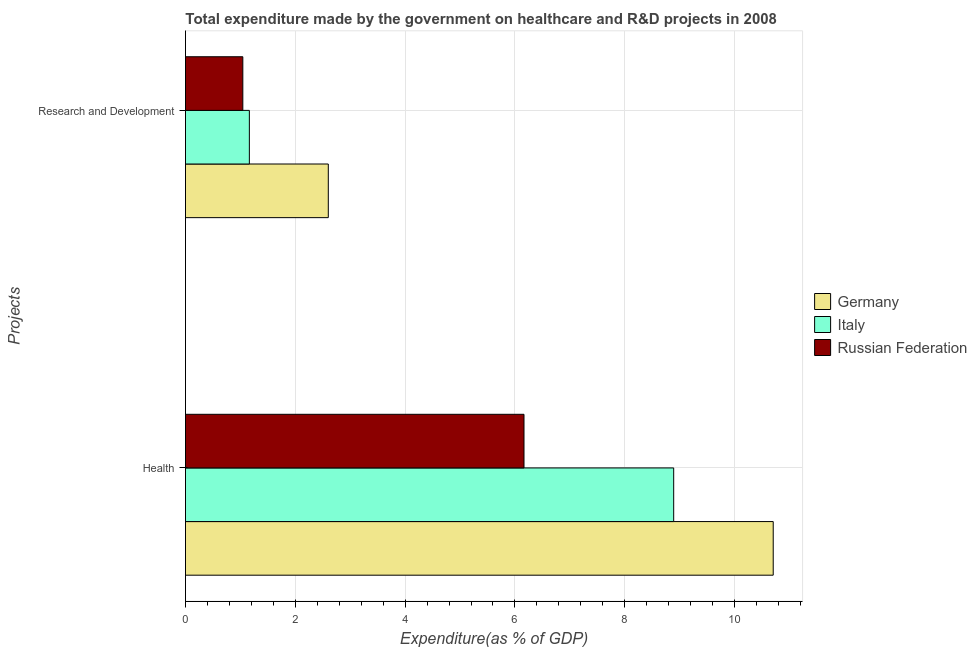How many different coloured bars are there?
Give a very brief answer. 3. How many groups of bars are there?
Provide a succinct answer. 2. Are the number of bars on each tick of the Y-axis equal?
Your response must be concise. Yes. How many bars are there on the 2nd tick from the bottom?
Provide a short and direct response. 3. What is the label of the 1st group of bars from the top?
Keep it short and to the point. Research and Development. What is the expenditure in healthcare in Russian Federation?
Provide a succinct answer. 6.17. Across all countries, what is the maximum expenditure in r&d?
Provide a short and direct response. 2.6. Across all countries, what is the minimum expenditure in healthcare?
Offer a terse response. 6.17. In which country was the expenditure in healthcare minimum?
Offer a terse response. Russian Federation. What is the total expenditure in r&d in the graph?
Provide a short and direct response. 4.81. What is the difference between the expenditure in healthcare in Italy and that in Germany?
Your response must be concise. -1.81. What is the difference between the expenditure in r&d in Russian Federation and the expenditure in healthcare in Italy?
Keep it short and to the point. -7.85. What is the average expenditure in r&d per country?
Keep it short and to the point. 1.6. What is the difference between the expenditure in r&d and expenditure in healthcare in Italy?
Your answer should be very brief. -7.73. What is the ratio of the expenditure in healthcare in Russian Federation to that in Germany?
Your answer should be compact. 0.58. Is the expenditure in healthcare in Italy less than that in Russian Federation?
Provide a succinct answer. No. What does the 2nd bar from the top in Research and Development represents?
Your answer should be compact. Italy. What does the 1st bar from the bottom in Research and Development represents?
Offer a very short reply. Germany. How many bars are there?
Give a very brief answer. 6. What is the difference between two consecutive major ticks on the X-axis?
Offer a terse response. 2. Are the values on the major ticks of X-axis written in scientific E-notation?
Offer a very short reply. No. Does the graph contain any zero values?
Give a very brief answer. No. How many legend labels are there?
Make the answer very short. 3. How are the legend labels stacked?
Offer a very short reply. Vertical. What is the title of the graph?
Your answer should be compact. Total expenditure made by the government on healthcare and R&D projects in 2008. Does "European Union" appear as one of the legend labels in the graph?
Provide a succinct answer. No. What is the label or title of the X-axis?
Provide a succinct answer. Expenditure(as % of GDP). What is the label or title of the Y-axis?
Ensure brevity in your answer.  Projects. What is the Expenditure(as % of GDP) of Germany in Health?
Offer a very short reply. 10.7. What is the Expenditure(as % of GDP) of Italy in Health?
Provide a succinct answer. 8.89. What is the Expenditure(as % of GDP) of Russian Federation in Health?
Provide a short and direct response. 6.17. What is the Expenditure(as % of GDP) of Germany in Research and Development?
Your answer should be compact. 2.6. What is the Expenditure(as % of GDP) of Italy in Research and Development?
Provide a short and direct response. 1.16. What is the Expenditure(as % of GDP) in Russian Federation in Research and Development?
Give a very brief answer. 1.04. Across all Projects, what is the maximum Expenditure(as % of GDP) of Germany?
Provide a short and direct response. 10.7. Across all Projects, what is the maximum Expenditure(as % of GDP) of Italy?
Make the answer very short. 8.89. Across all Projects, what is the maximum Expenditure(as % of GDP) in Russian Federation?
Offer a very short reply. 6.17. Across all Projects, what is the minimum Expenditure(as % of GDP) in Germany?
Make the answer very short. 2.6. Across all Projects, what is the minimum Expenditure(as % of GDP) in Italy?
Your answer should be compact. 1.16. Across all Projects, what is the minimum Expenditure(as % of GDP) of Russian Federation?
Make the answer very short. 1.04. What is the total Expenditure(as % of GDP) of Germany in the graph?
Ensure brevity in your answer.  13.3. What is the total Expenditure(as % of GDP) of Italy in the graph?
Provide a short and direct response. 10.05. What is the total Expenditure(as % of GDP) of Russian Federation in the graph?
Your response must be concise. 7.21. What is the difference between the Expenditure(as % of GDP) in Germany in Health and that in Research and Development?
Keep it short and to the point. 8.1. What is the difference between the Expenditure(as % of GDP) in Italy in Health and that in Research and Development?
Offer a very short reply. 7.73. What is the difference between the Expenditure(as % of GDP) in Russian Federation in Health and that in Research and Development?
Offer a terse response. 5.12. What is the difference between the Expenditure(as % of GDP) of Germany in Health and the Expenditure(as % of GDP) of Italy in Research and Development?
Your answer should be very brief. 9.54. What is the difference between the Expenditure(as % of GDP) in Germany in Health and the Expenditure(as % of GDP) in Russian Federation in Research and Development?
Keep it short and to the point. 9.66. What is the difference between the Expenditure(as % of GDP) in Italy in Health and the Expenditure(as % of GDP) in Russian Federation in Research and Development?
Give a very brief answer. 7.85. What is the average Expenditure(as % of GDP) in Germany per Projects?
Your answer should be very brief. 6.65. What is the average Expenditure(as % of GDP) of Italy per Projects?
Keep it short and to the point. 5.03. What is the average Expenditure(as % of GDP) in Russian Federation per Projects?
Keep it short and to the point. 3.6. What is the difference between the Expenditure(as % of GDP) of Germany and Expenditure(as % of GDP) of Italy in Health?
Keep it short and to the point. 1.81. What is the difference between the Expenditure(as % of GDP) of Germany and Expenditure(as % of GDP) of Russian Federation in Health?
Your answer should be compact. 4.54. What is the difference between the Expenditure(as % of GDP) in Italy and Expenditure(as % of GDP) in Russian Federation in Health?
Your response must be concise. 2.73. What is the difference between the Expenditure(as % of GDP) of Germany and Expenditure(as % of GDP) of Italy in Research and Development?
Your answer should be very brief. 1.44. What is the difference between the Expenditure(as % of GDP) of Germany and Expenditure(as % of GDP) of Russian Federation in Research and Development?
Give a very brief answer. 1.56. What is the difference between the Expenditure(as % of GDP) of Italy and Expenditure(as % of GDP) of Russian Federation in Research and Development?
Your response must be concise. 0.12. What is the ratio of the Expenditure(as % of GDP) in Germany in Health to that in Research and Development?
Make the answer very short. 4.12. What is the ratio of the Expenditure(as % of GDP) of Italy in Health to that in Research and Development?
Offer a very short reply. 7.64. What is the ratio of the Expenditure(as % of GDP) in Russian Federation in Health to that in Research and Development?
Your answer should be very brief. 5.9. What is the difference between the highest and the second highest Expenditure(as % of GDP) of Germany?
Offer a terse response. 8.1. What is the difference between the highest and the second highest Expenditure(as % of GDP) of Italy?
Provide a succinct answer. 7.73. What is the difference between the highest and the second highest Expenditure(as % of GDP) in Russian Federation?
Your answer should be compact. 5.12. What is the difference between the highest and the lowest Expenditure(as % of GDP) of Germany?
Offer a terse response. 8.1. What is the difference between the highest and the lowest Expenditure(as % of GDP) in Italy?
Your response must be concise. 7.73. What is the difference between the highest and the lowest Expenditure(as % of GDP) in Russian Federation?
Offer a terse response. 5.12. 